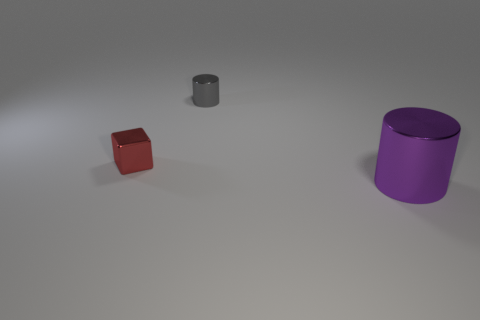There is a gray shiny cylinder; is it the same size as the object on the left side of the small cylinder?
Ensure brevity in your answer.  Yes. There is a small metallic thing right of the metallic cube; what shape is it?
Offer a terse response. Cylinder. Is the number of purple cylinders that are in front of the small gray metal thing greater than the number of small blue cylinders?
Provide a succinct answer. Yes. What number of small red metallic blocks are behind the tiny metallic thing on the left side of the cylinder left of the purple metal object?
Your answer should be very brief. 0. Do the metallic cylinder in front of the tiny red shiny block and the shiny object that is behind the tiny red block have the same size?
Ensure brevity in your answer.  No. What number of objects are either metal cylinders behind the small red object or tiny cylinders?
Offer a very short reply. 1. Are there the same number of large purple cylinders left of the large purple shiny object and metal cylinders that are in front of the tiny cube?
Ensure brevity in your answer.  No. The cylinder behind the cylinder that is on the right side of the metal thing that is behind the block is made of what material?
Your answer should be very brief. Metal. There is a shiny object that is both right of the tiny red cube and in front of the small gray cylinder; how big is it?
Make the answer very short. Large. Do the purple metallic thing and the gray metal thing have the same shape?
Your response must be concise. Yes. 